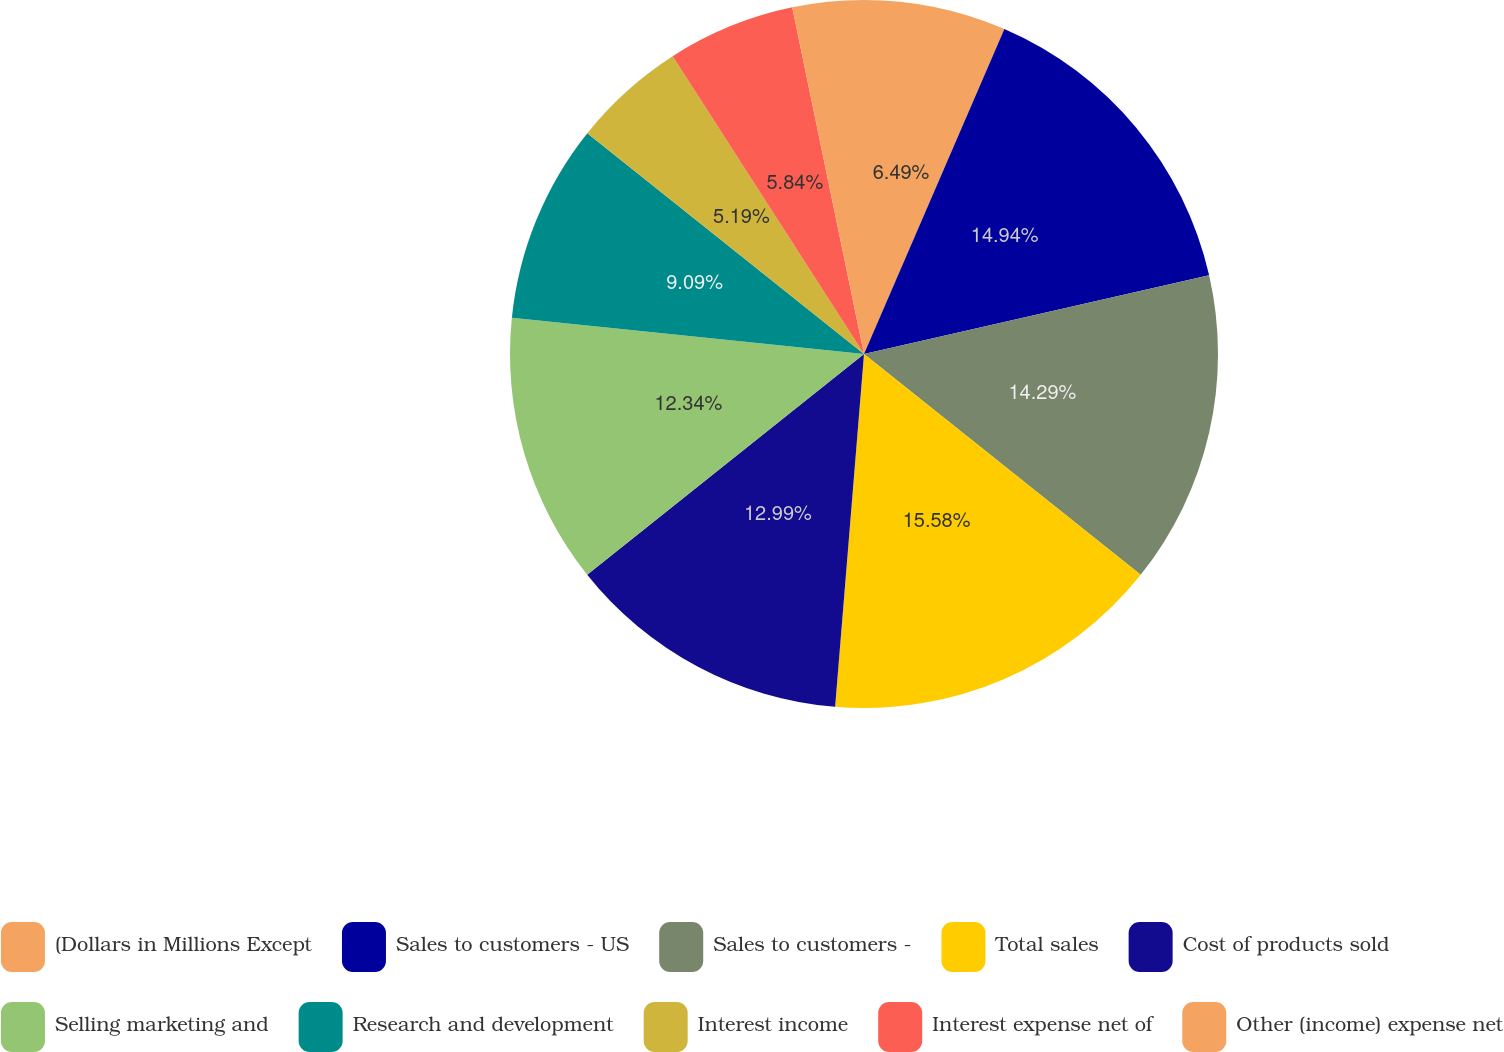Convert chart to OTSL. <chart><loc_0><loc_0><loc_500><loc_500><pie_chart><fcel>(Dollars in Millions Except<fcel>Sales to customers - US<fcel>Sales to customers -<fcel>Total sales<fcel>Cost of products sold<fcel>Selling marketing and<fcel>Research and development<fcel>Interest income<fcel>Interest expense net of<fcel>Other (income) expense net<nl><fcel>6.49%<fcel>14.94%<fcel>14.29%<fcel>15.58%<fcel>12.99%<fcel>12.34%<fcel>9.09%<fcel>5.19%<fcel>5.84%<fcel>3.25%<nl></chart> 